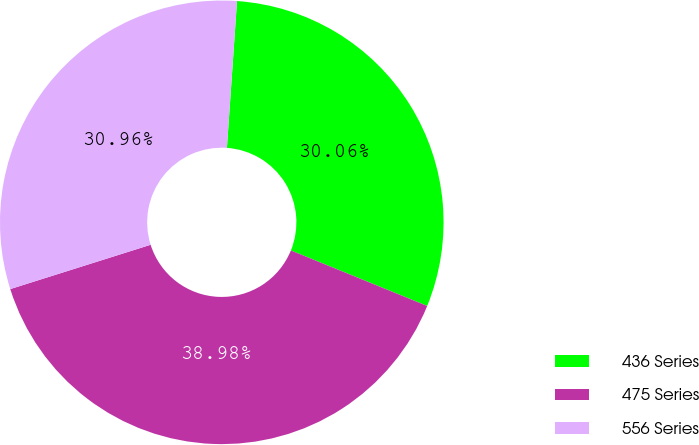Convert chart. <chart><loc_0><loc_0><loc_500><loc_500><pie_chart><fcel>436 Series<fcel>475 Series<fcel>556 Series<nl><fcel>30.06%<fcel>38.98%<fcel>30.96%<nl></chart> 